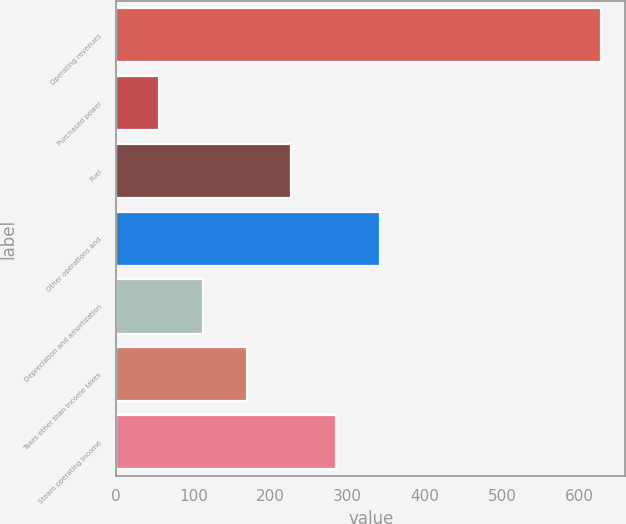<chart> <loc_0><loc_0><loc_500><loc_500><bar_chart><fcel>Operating revenues<fcel>Purchased power<fcel>Fuel<fcel>Other operations and<fcel>Depreciation and amortization<fcel>Taxes other than income taxes<fcel>Steam operating income<nl><fcel>628<fcel>55<fcel>226.9<fcel>341.5<fcel>112.3<fcel>169.6<fcel>284.2<nl></chart> 